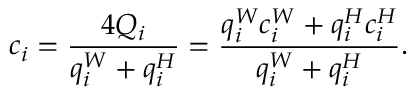<formula> <loc_0><loc_0><loc_500><loc_500>c _ { i } = \frac { 4 Q _ { i } } { q _ { i } ^ { W } + q _ { i } ^ { H } } = \frac { q _ { i } ^ { W } c _ { i } ^ { W } + q _ { i } ^ { H } c _ { i } ^ { H } } { q _ { i } ^ { W } + q _ { i } ^ { H } } .</formula> 